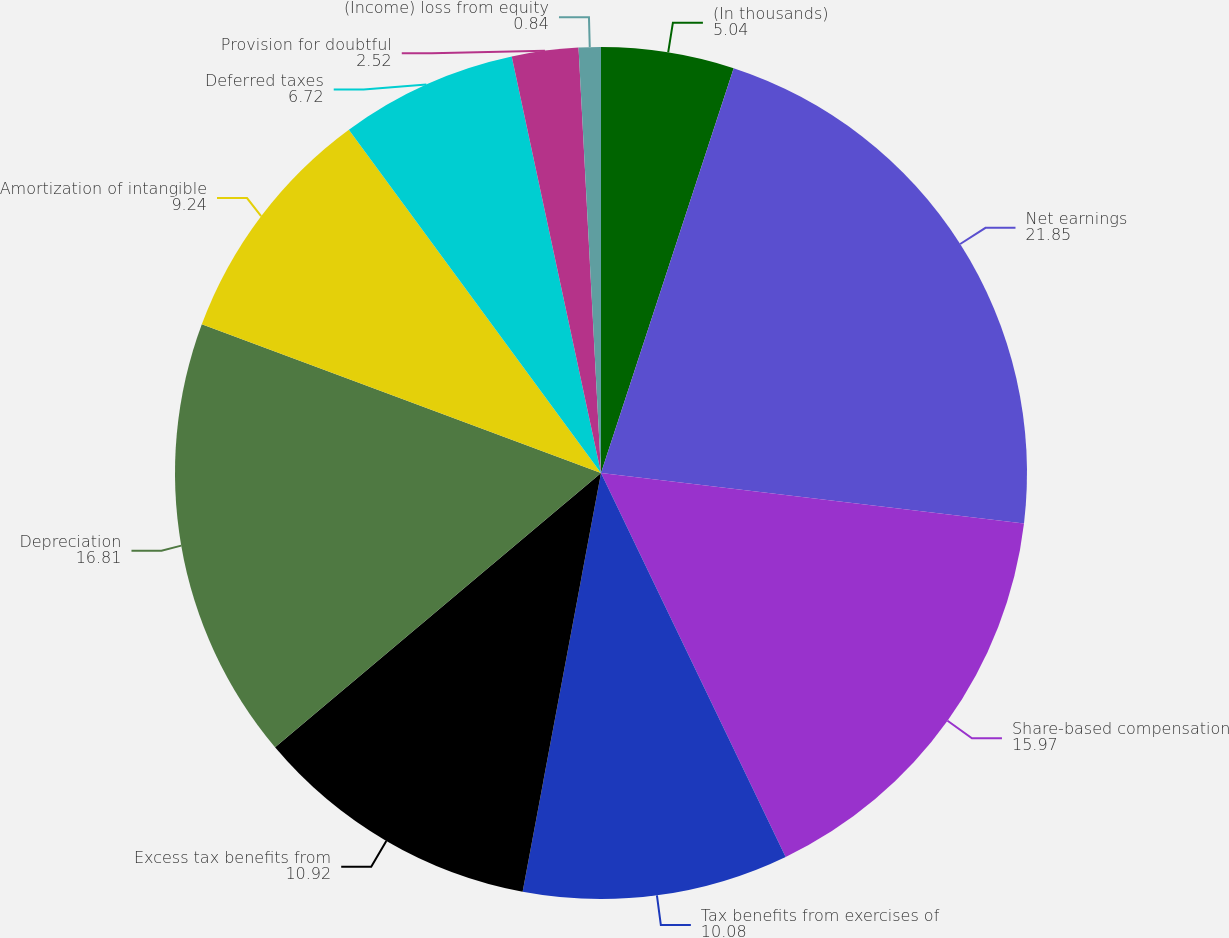Convert chart to OTSL. <chart><loc_0><loc_0><loc_500><loc_500><pie_chart><fcel>(In thousands)<fcel>Net earnings<fcel>Share-based compensation<fcel>Tax benefits from exercises of<fcel>Excess tax benefits from<fcel>Depreciation<fcel>Amortization of intangible<fcel>Deferred taxes<fcel>Provision for doubtful<fcel>(Income) loss from equity<nl><fcel>5.04%<fcel>21.85%<fcel>15.97%<fcel>10.08%<fcel>10.92%<fcel>16.81%<fcel>9.24%<fcel>6.72%<fcel>2.52%<fcel>0.84%<nl></chart> 